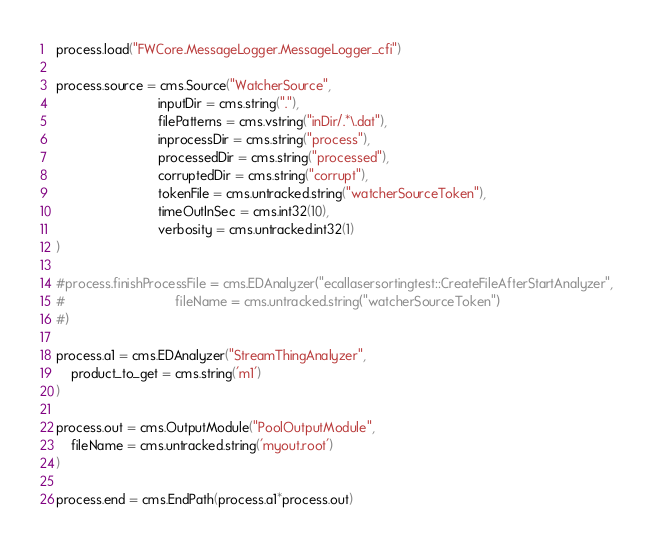Convert code to text. <code><loc_0><loc_0><loc_500><loc_500><_Python_>
process.load("FWCore.MessageLogger.MessageLogger_cfi")

process.source = cms.Source("WatcherSource",
                            inputDir = cms.string("."),
                            filePatterns = cms.vstring("inDir/.*\.dat"),
                            inprocessDir = cms.string("process"),
                            processedDir = cms.string("processed"),
                            corruptedDir = cms.string("corrupt"),
                            tokenFile = cms.untracked.string("watcherSourceToken"),
                            timeOutInSec = cms.int32(10),
                            verbosity = cms.untracked.int32(1)
)

#process.finishProcessFile = cms.EDAnalyzer("ecallasersortingtest::CreateFileAfterStartAnalyzer",
#                              fileName = cms.untracked.string("watcherSourceToken")
#)

process.a1 = cms.EDAnalyzer("StreamThingAnalyzer",
    product_to_get = cms.string('m1')
)

process.out = cms.OutputModule("PoolOutputModule",
    fileName = cms.untracked.string('myout.root')
)

process.end = cms.EndPath(process.a1*process.out)
</code> 